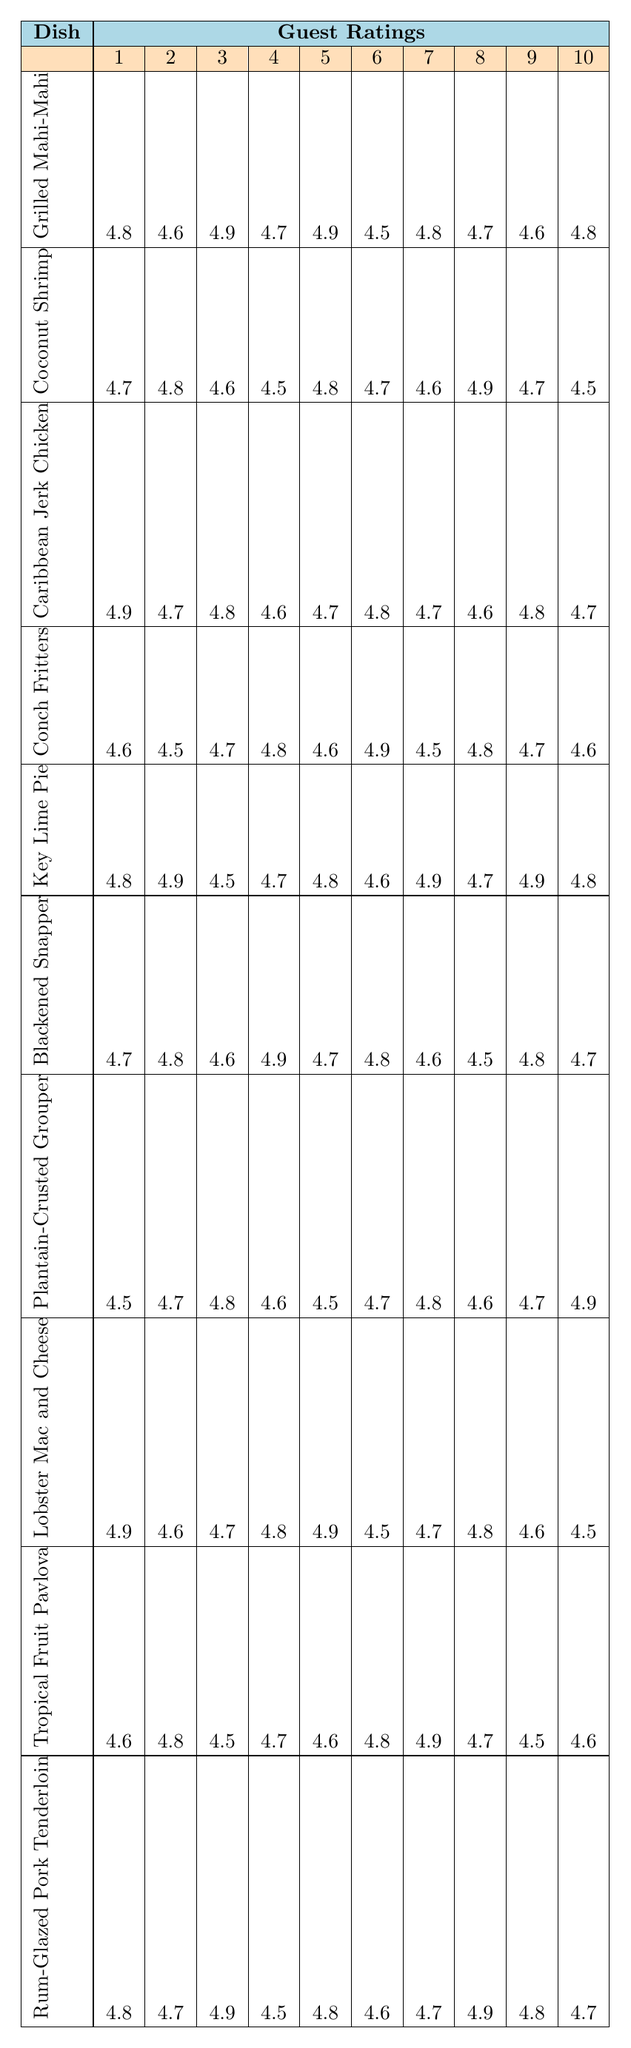What is the highest rating for the Coconut Shrimp dish? From the table, I can look at the row for Coconut Shrimp and find the highest value among the ratings listed. The values are 4.7, 4.8, 4.6, 4.5, 4.8, 4.7, 4.6, 4.9, 4.7, 4.5. The highest rating is 4.9.
Answer: 4.9 Which dish received the lowest rating overall? To determine the lowest rating overall, I need to look at all the dishes and their ratings. After checking each dish's ratings, I find that the dish with the lowest rating is the Conch Fritters, where the lowest score it received is 4.5.
Answer: Conch Fritters What is the average rating for the Key Lime Pie? I add up all ten ratings for Key Lime Pie: 4.8 + 4.9 + 4.5 + 4.7 + 4.8 + 4.6 + 4.9 + 4.7 + 4.9 + 4.8 = 48.6. Then, I divide the sum by 10 (the number of ratings), which gives me an average of 4.86.
Answer: 4.86 How many dishes have an average rating above 4.7? First, I need to calculate the average rating for each dish. I find that Grilled Mahi-Mahi (4.74), Coconut Shrimp (4.66), Caribbean Jerk Chicken (4.74), Conch Fritters (4.62), Key Lime Pie (4.78), Blackened Snapper (4.72), Plantain-Crusted Grouper (4.66), Lobster Mac and Cheese (4.64), Tropical Fruit Pavlova (4.64), and Rum-Glazed Pork Tenderloin (4.75) have average ratings. The dishes with averages above 4.7 are Grilled Mahi-Mahi, Caribbean Jerk Chicken, Key Lime Pie, Blackened Snapper, and Rum-Glazed Pork Tenderloin. Thus, there are 5 dishes.
Answer: 5 Is there a dish that has a perfect rating of 5.0? I scan through all the ratings for each dish and see that none of the dishes received a perfect score of 5.0. Therefore, no dish has a rating of 5.0.
Answer: No What is the difference between the highest and lowest ratings for the Tropical Fruit Pavlova? For the Tropical Fruit Pavlova, the ratings are 4.6, 4.8, 4.5, 4.7, 4.6, 4.8, 4.9, 4.7, 4.5, and 4.6. The highest rating is 4.9 and the lowest is 4.5. I find the difference by subtracting: 4.9 - 4.5 = 0.4.
Answer: 0.4 Which dish had the most consistent ratings, and how do I know? To determine the most consistent dish, I can calculate the range of ratings (the difference between the highest and lowest ratings) for each dish. The dish with the smallest range indicates more consistency. Upon analyzing the data, Plantain-Crusted Grouper has ratings that range from 4.5 to 4.9, a total range of 0.4, which is the smallest range among all dishes.
Answer: Plantain-Crusted Grouper Which dish received the highest rating among the 10 ratings? I need to examine all the ratings across all dishes to find the maximum value. After checking the ratings, I find that the highest rating is 4.9, and it was received by multiple dishes such as Grilled Mahi-Mahi, Caribbean Jerk Chicken, and Key Lime Pie.
Answer: Grilled Mahi-Mahi (among others) 